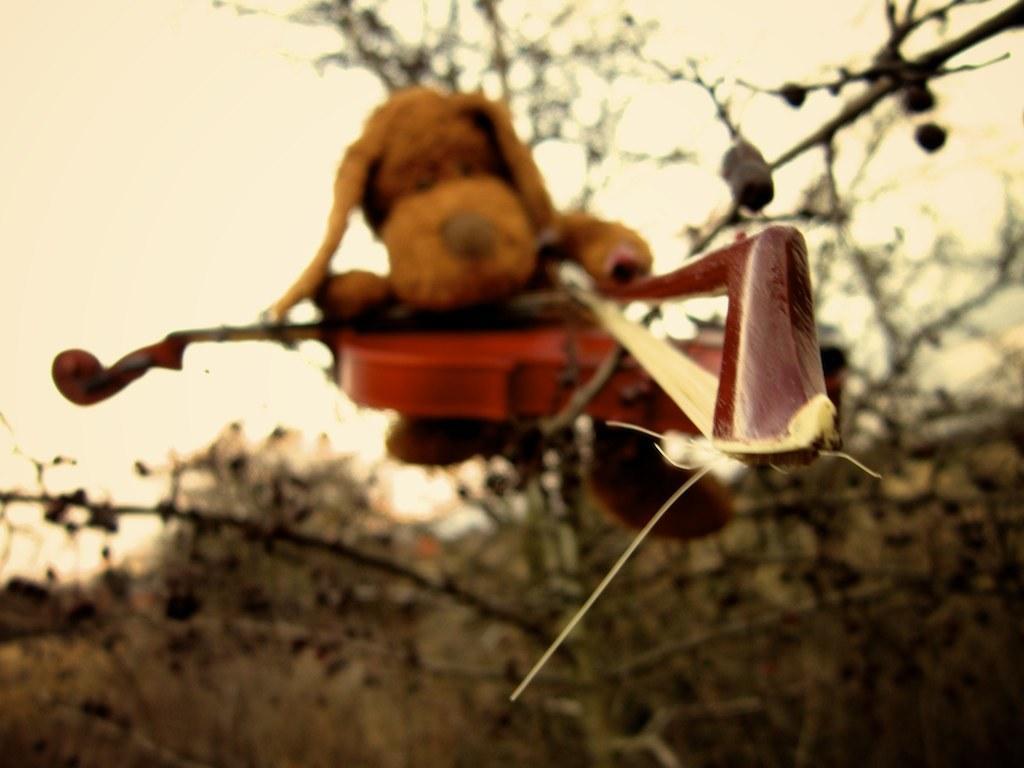How would you summarize this image in a sentence or two? In the foreground of this image, there is a toy and guitar on a tree. In the background, there are trees and the sky. 